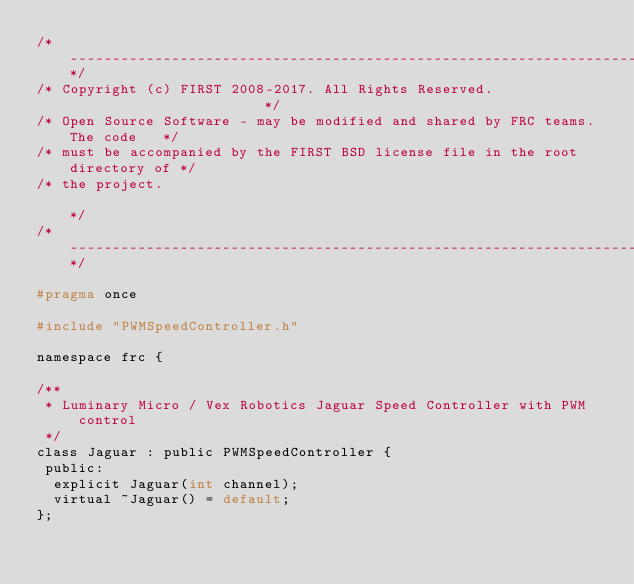<code> <loc_0><loc_0><loc_500><loc_500><_C_>/*----------------------------------------------------------------------------*/
/* Copyright (c) FIRST 2008-2017. All Rights Reserved.                        */
/* Open Source Software - may be modified and shared by FRC teams. The code   */
/* must be accompanied by the FIRST BSD license file in the root directory of */
/* the project.                                                               */
/*----------------------------------------------------------------------------*/

#pragma once

#include "PWMSpeedController.h"

namespace frc {

/**
 * Luminary Micro / Vex Robotics Jaguar Speed Controller with PWM control
 */
class Jaguar : public PWMSpeedController {
 public:
  explicit Jaguar(int channel);
  virtual ~Jaguar() = default;
};
</code> 